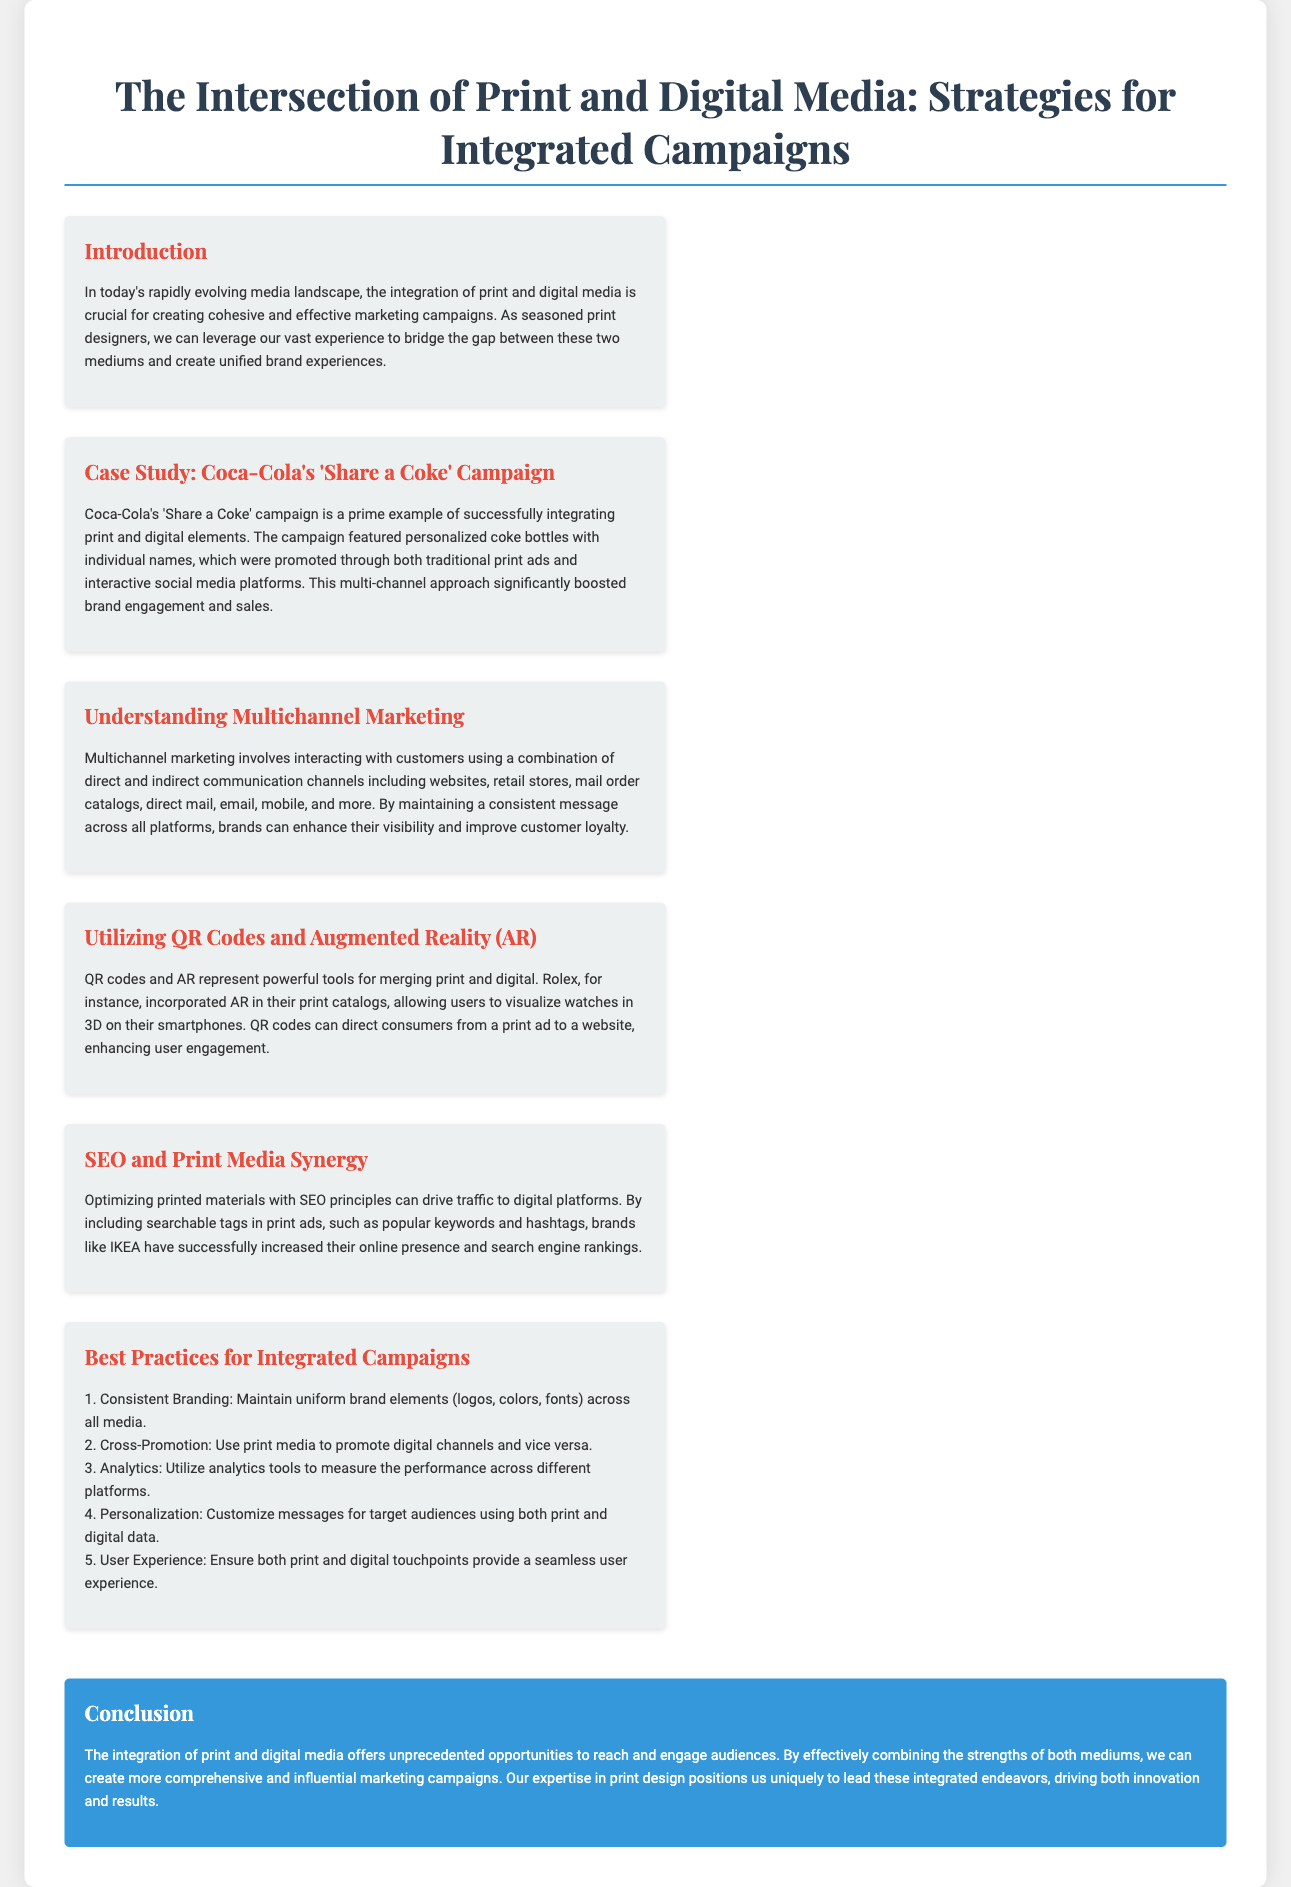What is the title of the presentation? The title is clearly stated at the top of the document as the heading.
Answer: The Intersection of Print and Digital Media: Strategies for Integrated Campaigns Which campaign is used as a case study? The case study section discusses a specific marketing campaign that links print and digital media.
Answer: Coca-Cola's 'Share a Coke' Campaign What is one tool mentioned for merging print and digital? The section discusses technological tools that can bridge the two media forms.
Answer: QR Codes What does the acronym SEO stand for? The document references various marketing strategies including this acronym.
Answer: Search Engine Optimization Name one best practice for integrated campaigns. The section outlines key strategies for creating successful campaigns that combine both media formats.
Answer: Consistent Branding What color is used for the conclusion section background? The color is specifically described in the presentation to distinguish the conclusion from other sections.
Answer: Blue Which brand successfully used SEO principles in their print media? The document provides an example of a brand that optimized printed materials for digital traffic.
Answer: IKEA What audience strategy is proposed in the best practices? The document suggests a specific approach to catering to audiences in marketing campaigns.
Answer: Personalization How is the overarching theme of the presentation described? The conclusion summarizes the integration of both media forms as a unique marketing advantage.
Answer: Cohesive and effective marketing campaigns 